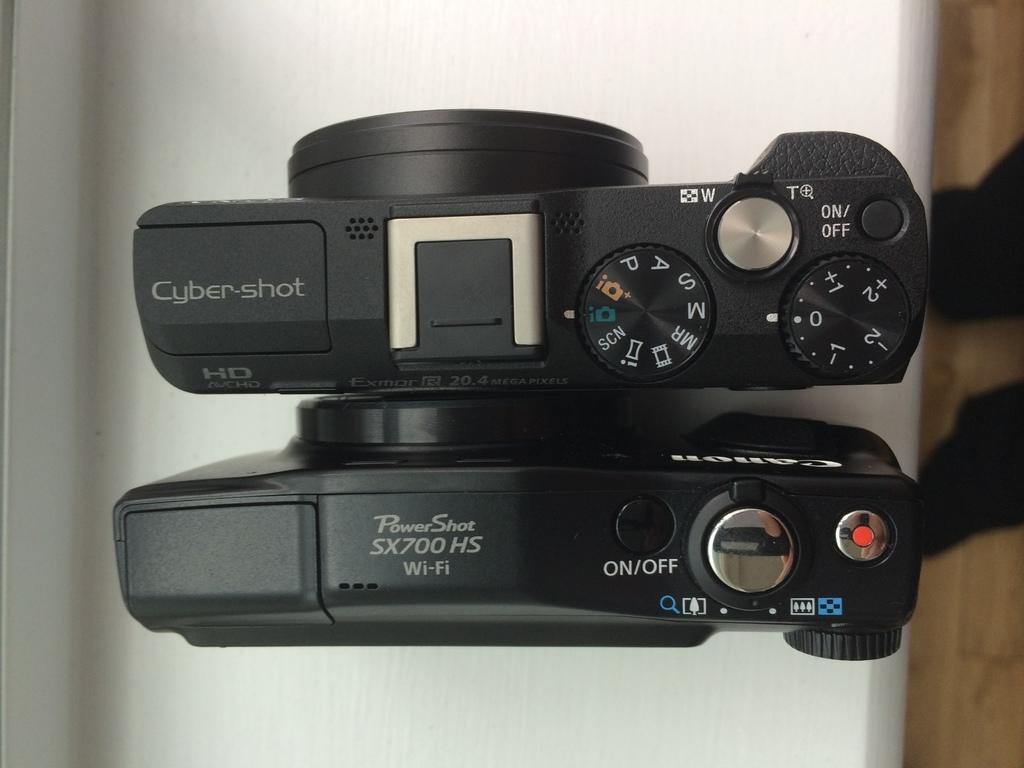<image>
Provide a brief description of the given image. A Cyber-shot camera is next to a PowerShot camera on a white counter. 